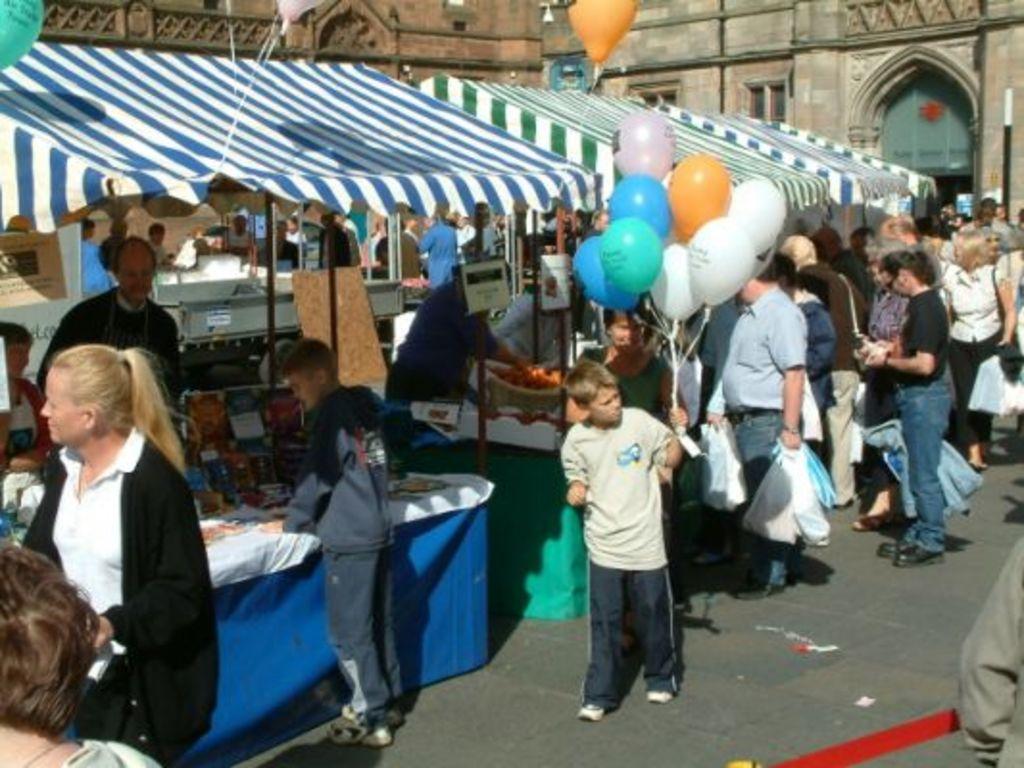Describe this image in one or two sentences. There is a boy in a t-shirt, holding balloons, which are in different colors on the road, near shops, which are having tents and near other persons. Who are standing on the road. In the background, there is a building and other objects. 